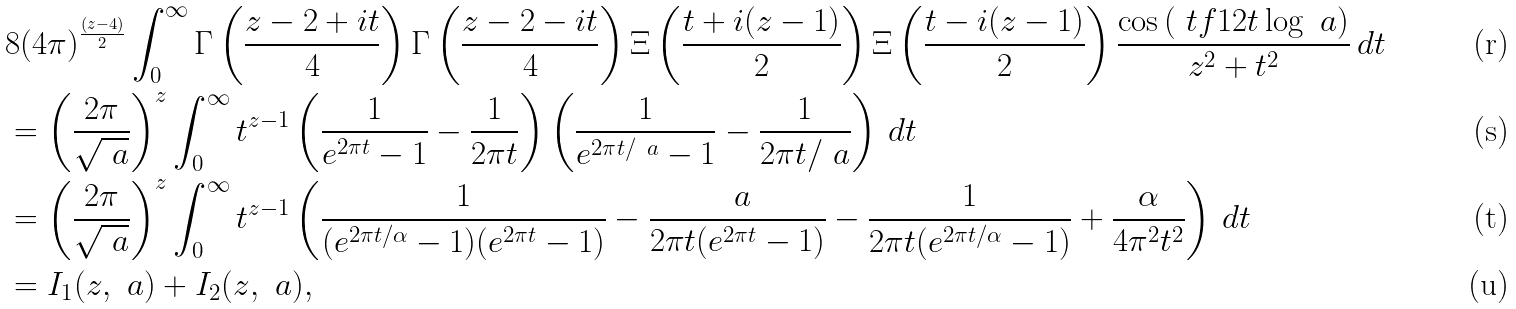Convert formula to latex. <formula><loc_0><loc_0><loc_500><loc_500>& 8 ( 4 \pi ) ^ { \frac { ( z - 4 ) } { 2 } } \int _ { 0 } ^ { \infty } \Gamma \left ( \frac { z - 2 + i t } { 4 } \right ) \Gamma \left ( \frac { z - 2 - i t } { 4 } \right ) \Xi \left ( \frac { t + i ( z - 1 ) } { 2 } \right ) \Xi \left ( \frac { t - i ( z - 1 ) } { 2 } \right ) \frac { \cos \left ( \ t f { 1 } { 2 } t \log \ a \right ) } { z ^ { 2 } + t ^ { 2 } } \, d t \\ & = \left ( \frac { 2 \pi } { \sqrt { \ a } } \right ) ^ { z } \int _ { 0 } ^ { \infty } t ^ { z - 1 } \left ( \frac { 1 } { e ^ { 2 \pi t } - 1 } - \frac { 1 } { 2 \pi t } \right ) \left ( \frac { 1 } { e ^ { 2 \pi t / \ a } - 1 } - \frac { 1 } { 2 \pi t / \ a } \right ) \, d t \\ & = \left ( \frac { 2 \pi } { \sqrt { \ a } } \right ) ^ { z } \int _ { 0 } ^ { \infty } t ^ { z - 1 } \left ( \frac { 1 } { ( e ^ { 2 \pi t / \alpha } - 1 ) ( e ^ { 2 \pi t } - 1 ) } - \frac { \ a } { 2 \pi t ( e ^ { 2 \pi t } - 1 ) } - \frac { 1 } { 2 \pi t ( e ^ { 2 \pi t / \alpha } - 1 ) } + \frac { \alpha } { 4 \pi ^ { 2 } t ^ { 2 } } \right ) \, d t \\ & = I _ { 1 } ( z , \ a ) + I _ { 2 } ( z , \ a ) ,</formula> 